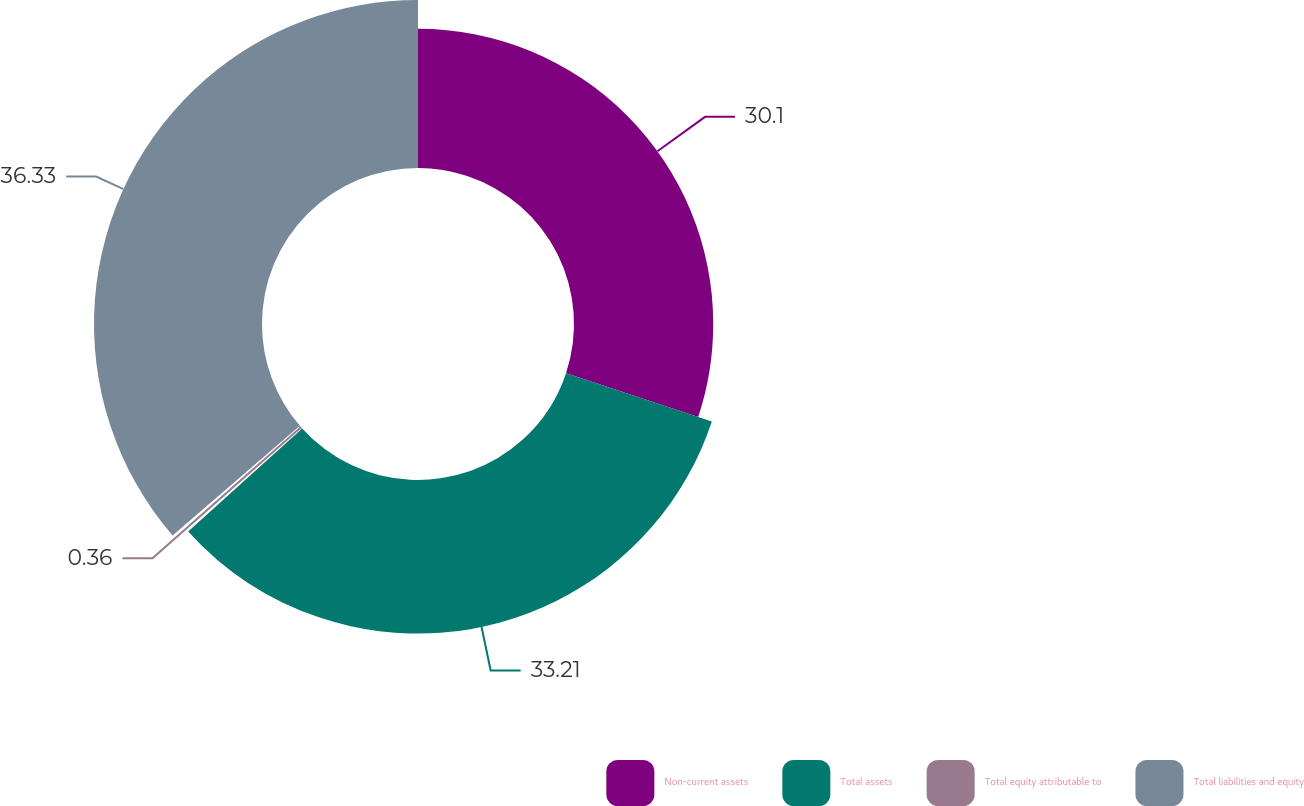<chart> <loc_0><loc_0><loc_500><loc_500><pie_chart><fcel>Non-current assets<fcel>Total assets<fcel>Total equity attributable to<fcel>Total liabilities and equity<nl><fcel>30.1%<fcel>33.21%<fcel>0.36%<fcel>36.32%<nl></chart> 